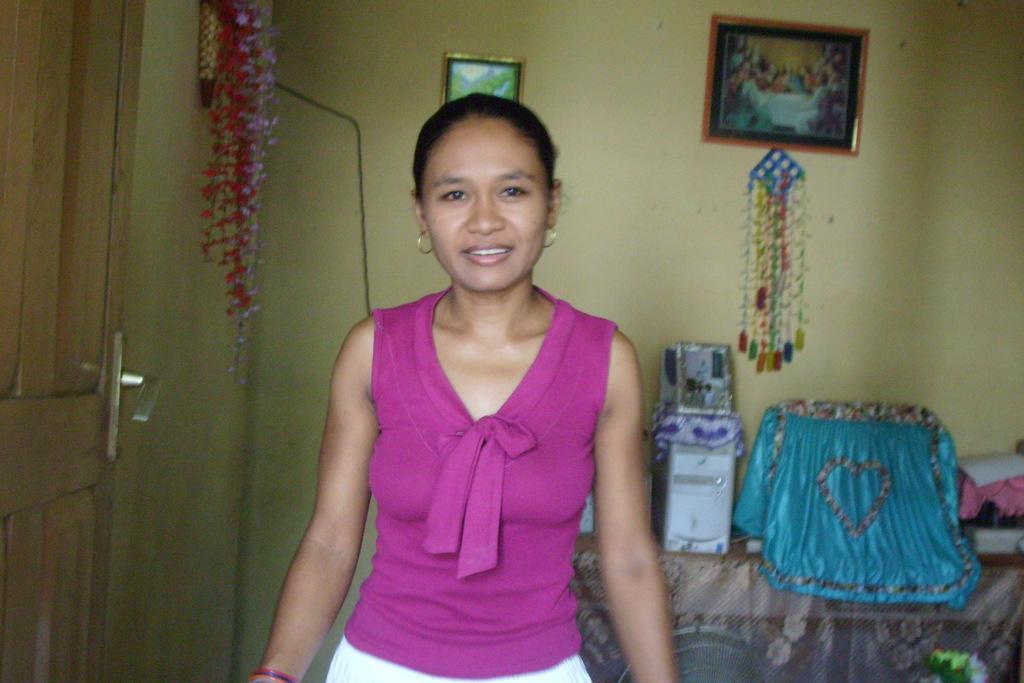In one or two sentences, can you explain what this image depicts? In this image there is a woman with a smile on her face, behind the woman there is a door some photo frames with some objects on the wall and there is a CPU, a monitor and some objects on the table. 